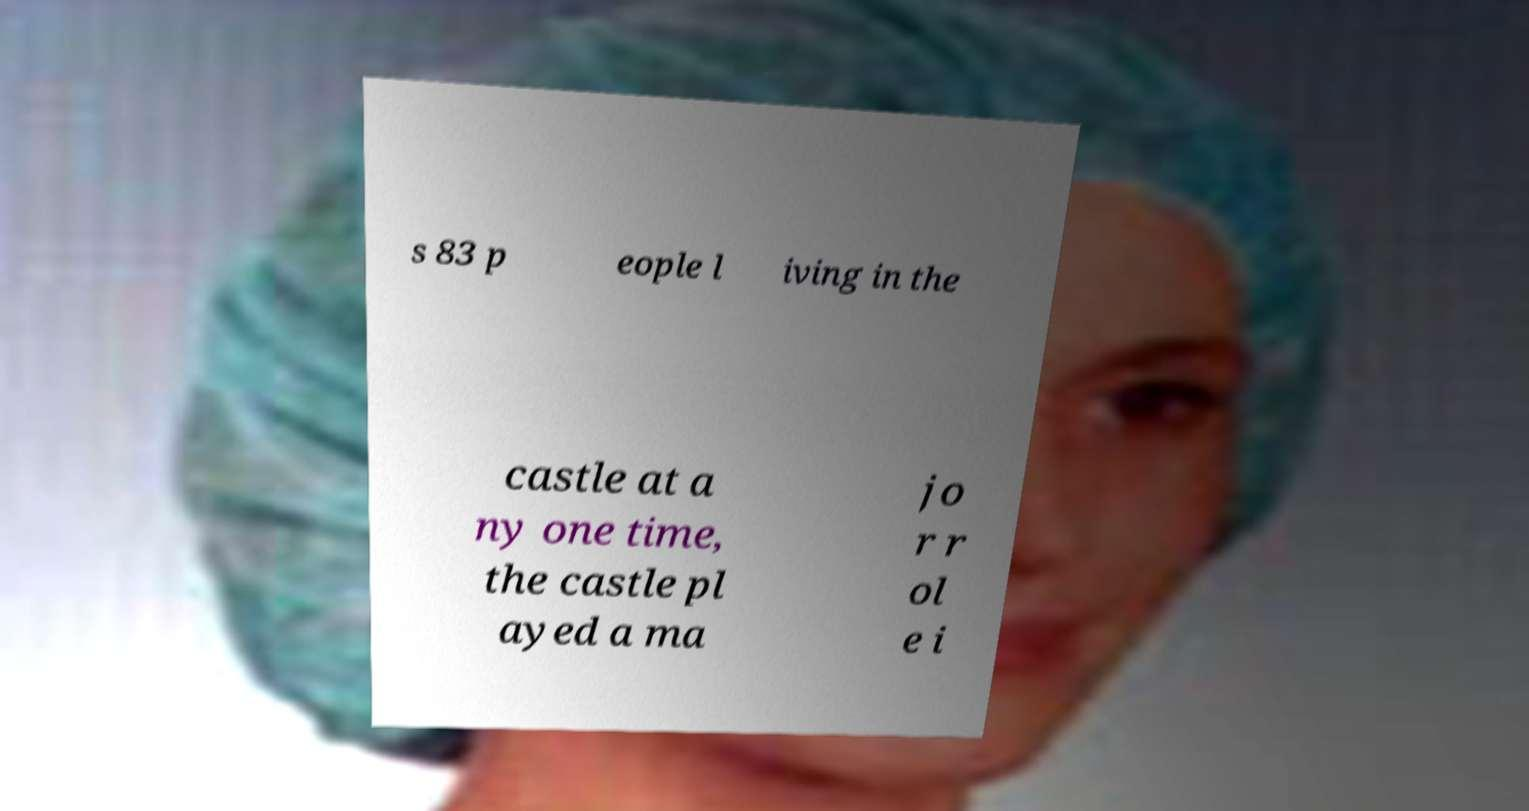Could you extract and type out the text from this image? s 83 p eople l iving in the castle at a ny one time, the castle pl ayed a ma jo r r ol e i 